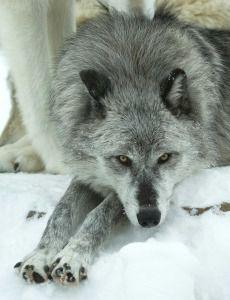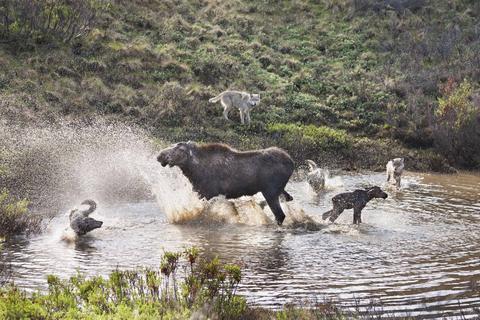The first image is the image on the left, the second image is the image on the right. Examine the images to the left and right. Is the description "One image features a wolf on snowy ground, and the other includes a body of water and at least one wolf." accurate? Answer yes or no. Yes. The first image is the image on the left, the second image is the image on the right. Assess this claim about the two images: "A single wolf is in a watery area in the image on the right.". Correct or not? Answer yes or no. No. 